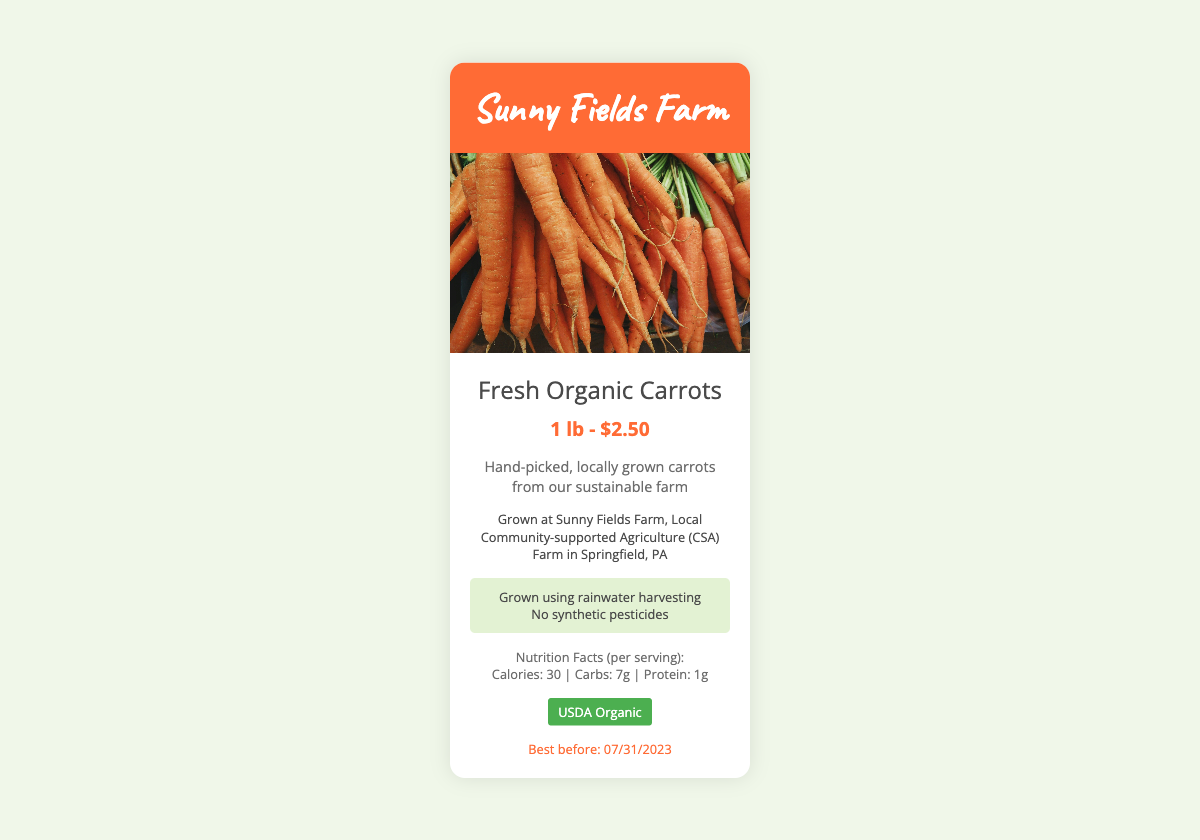What is the product name? The product name is prominently displayed in the document.
Answer: Fresh Organic Carrots What is the price for one pound? The price is found in the product information section.
Answer: 1 lb - $2.50 Where is the farm located? The farm's location is mentioned under the farm information section.
Answer: Springfield, PA What is the expiration date? The expiration date is indicated towards the end of the product info section.
Answer: 07/31/2023 What type of farming practices are mentioned? The sustainability section details the farming practices used.
Answer: rainwater harvesting, No synthetic pesticides What certification does the product have? The certification is clearly displayed in a specific section of the document.
Answer: USDA Organic How many calories are in a serving? The nutrition facts provide specific calorie information.
Answer: 30 What is the main color of the logo background? The background color of the logo is mentioned visually in the design.
Answer: #ff6b35 What farming initiative does this product belong to? The initiative is derived from the information regarding the farm's community involvement.
Answer: Community-supported Agriculture (CSA) Farm 